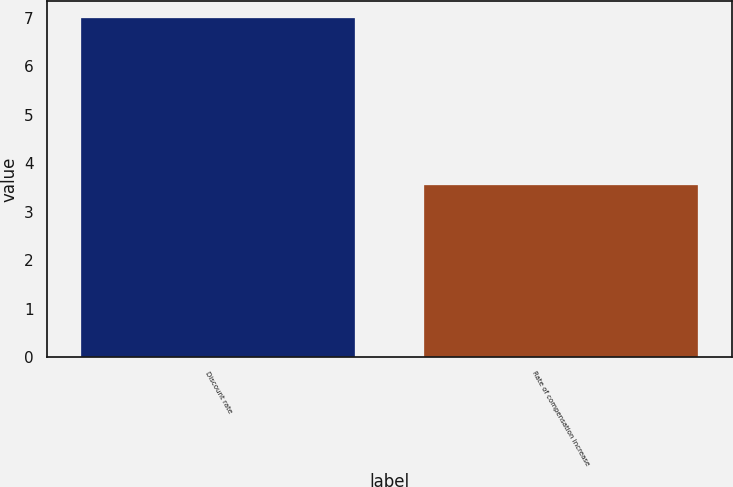<chart> <loc_0><loc_0><loc_500><loc_500><bar_chart><fcel>Discount rate<fcel>Rate of compensation increase<nl><fcel>7<fcel>3.55<nl></chart> 